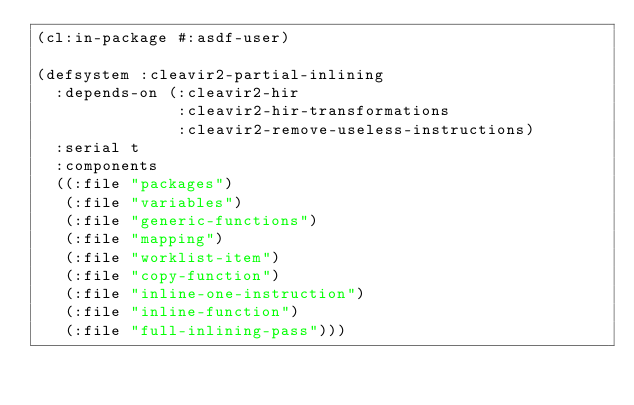<code> <loc_0><loc_0><loc_500><loc_500><_Lisp_>(cl:in-package #:asdf-user)

(defsystem :cleavir2-partial-inlining
  :depends-on (:cleavir2-hir
               :cleavir2-hir-transformations
               :cleavir2-remove-useless-instructions)
  :serial t
  :components
  ((:file "packages")
   (:file "variables")
   (:file "generic-functions")
   (:file "mapping")
   (:file "worklist-item")
   (:file "copy-function")
   (:file "inline-one-instruction")
   (:file "inline-function")
   (:file "full-inlining-pass")))
</code> 